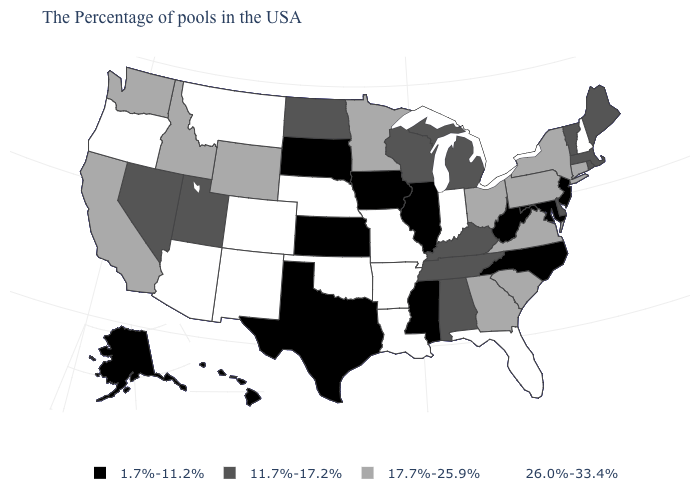Which states hav the highest value in the West?
Answer briefly. Colorado, New Mexico, Montana, Arizona, Oregon. Which states have the lowest value in the MidWest?
Be succinct. Illinois, Iowa, Kansas, South Dakota. What is the value of Illinois?
Quick response, please. 1.7%-11.2%. What is the value of New Mexico?
Be succinct. 26.0%-33.4%. Does Washington have a lower value than Colorado?
Be succinct. Yes. Does Arizona have a higher value than Oklahoma?
Quick response, please. No. What is the lowest value in the West?
Short answer required. 1.7%-11.2%. What is the value of Hawaii?
Write a very short answer. 1.7%-11.2%. Does Florida have a higher value than Nebraska?
Give a very brief answer. No. Among the states that border Michigan , does Indiana have the lowest value?
Write a very short answer. No. Name the states that have a value in the range 17.7%-25.9%?
Keep it brief. Connecticut, New York, Pennsylvania, Virginia, South Carolina, Ohio, Georgia, Minnesota, Wyoming, Idaho, California, Washington. Does Minnesota have the lowest value in the USA?
Keep it brief. No. Is the legend a continuous bar?
Quick response, please. No. Among the states that border Washington , which have the highest value?
Answer briefly. Oregon. What is the highest value in states that border West Virginia?
Keep it brief. 17.7%-25.9%. 